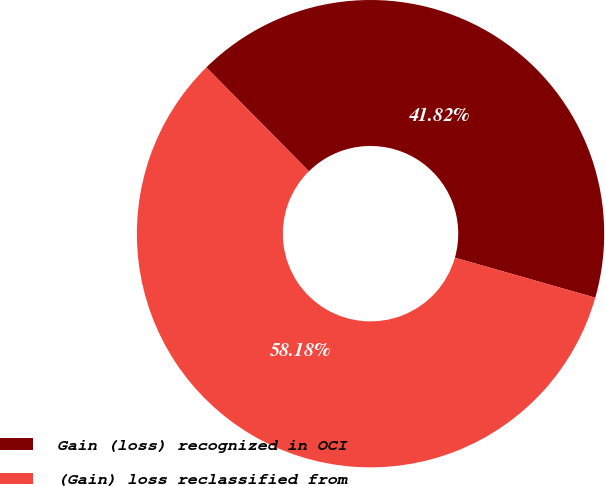Convert chart to OTSL. <chart><loc_0><loc_0><loc_500><loc_500><pie_chart><fcel>Gain (loss) recognized in OCI<fcel>(Gain) loss reclassified from<nl><fcel>41.82%<fcel>58.18%<nl></chart> 